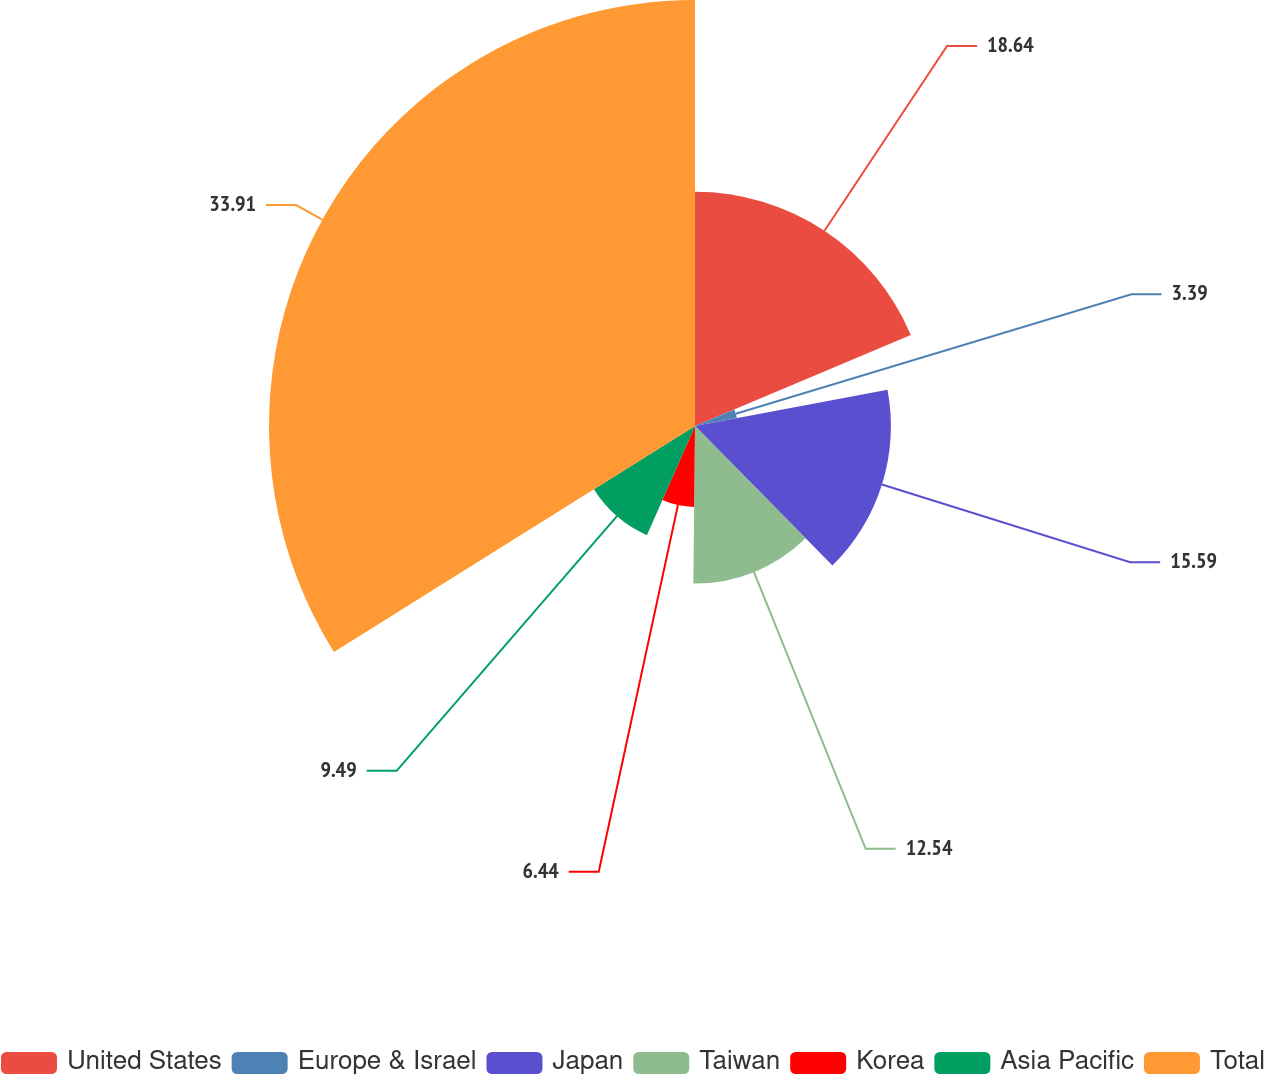Convert chart to OTSL. <chart><loc_0><loc_0><loc_500><loc_500><pie_chart><fcel>United States<fcel>Europe & Israel<fcel>Japan<fcel>Taiwan<fcel>Korea<fcel>Asia Pacific<fcel>Total<nl><fcel>18.64%<fcel>3.39%<fcel>15.59%<fcel>12.54%<fcel>6.44%<fcel>9.49%<fcel>33.9%<nl></chart> 